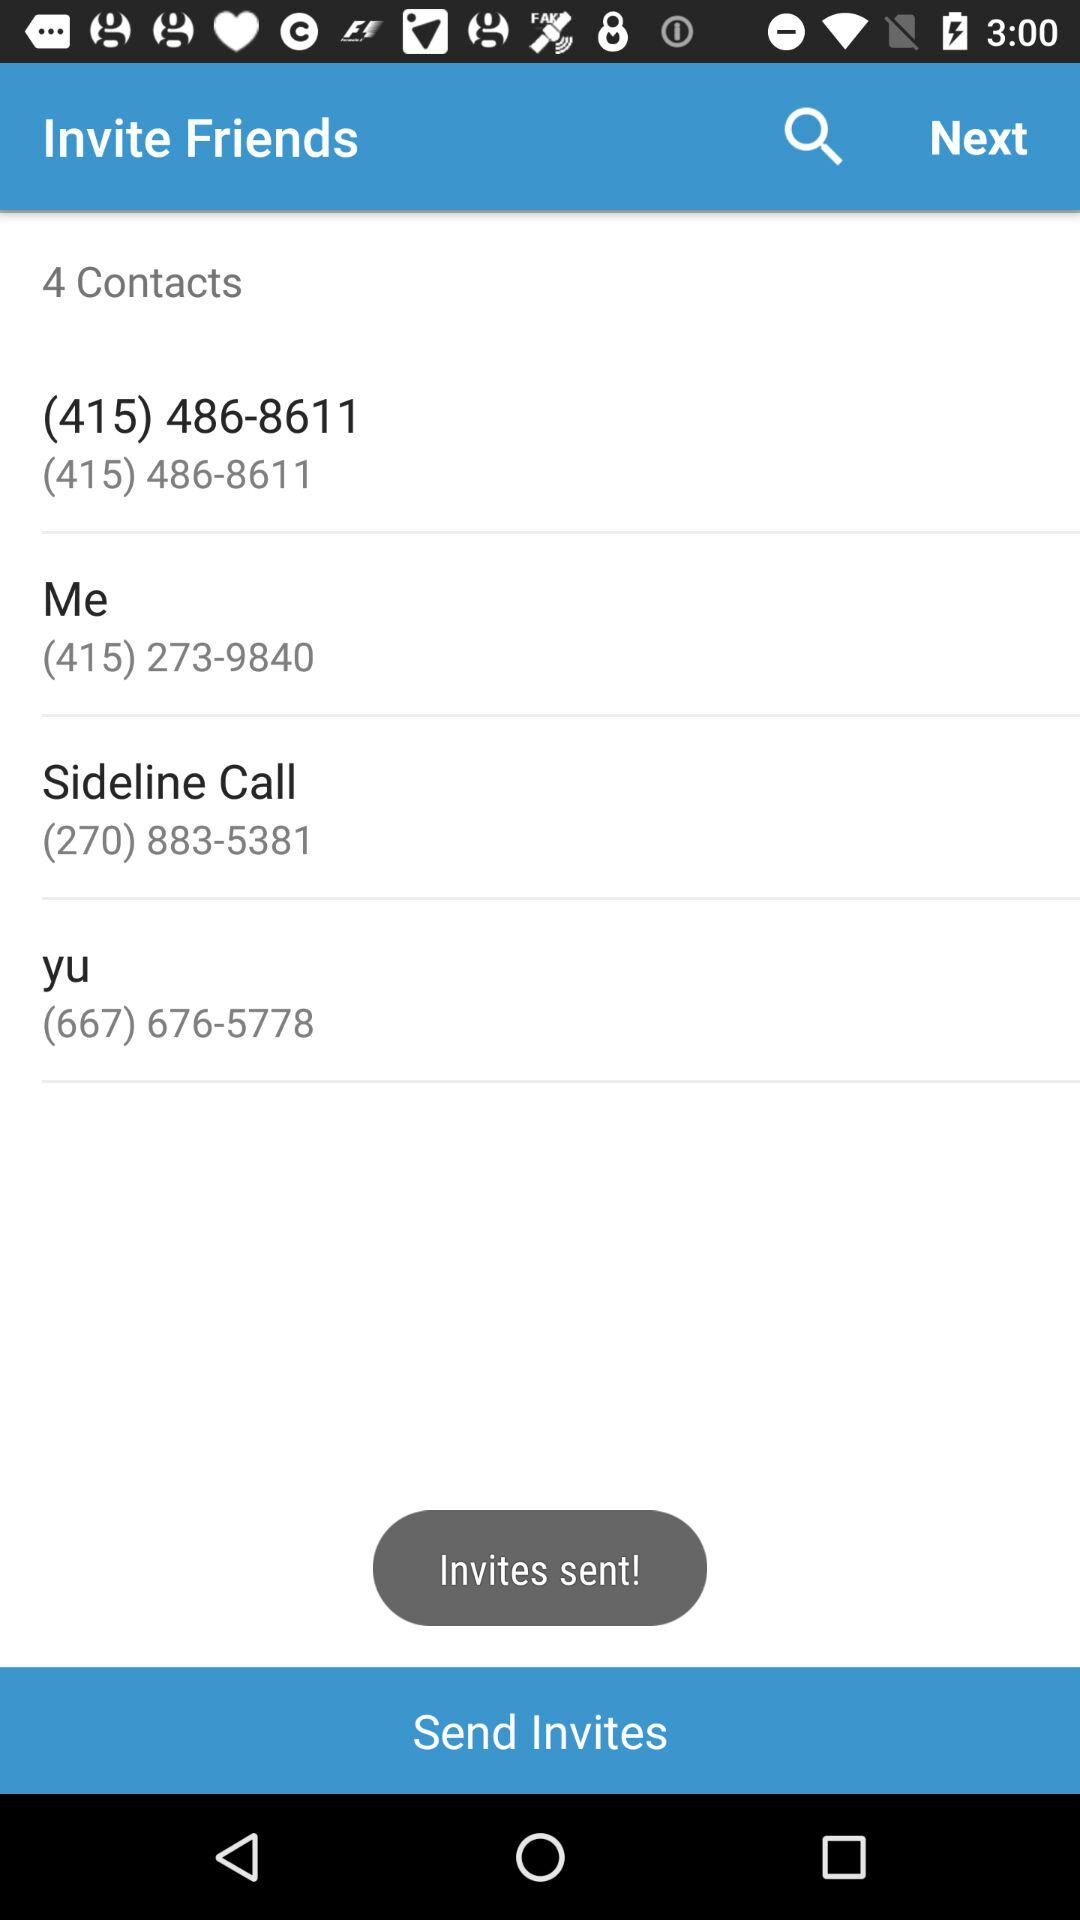What is the contact number of "ME"? The contact number is (415) 273-9840. 